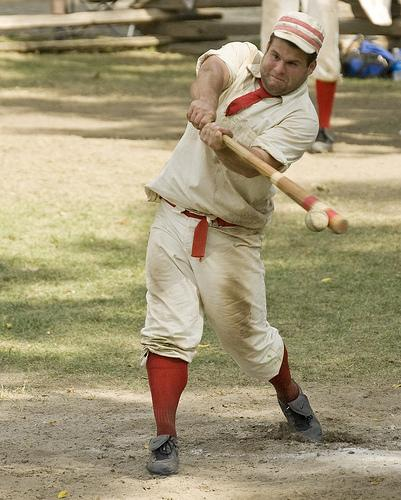State three details about the man's attire and accessories. The man is wearing a red and white hat, a red tie around his neck, and a red belt on his pants. List five objects you can see in the picture. A baseball player, wooden bat, red sock, black shoe, white baseball. What specific action is the baseball player attempting to perform? The baseball player is attempting to hit the white baseball coming towards him using a wooden bat. Mention the color and position of the sock and the shoe. The red sock is on the leg, and the black shoe is on the foot. In a dramatic fashion, describe the interaction between the baseball and the bat during the swing. As the white baseball soars through the air, the determined batter lunges his wooden bat with fierce calculation, destiny hurtling them towards a fateful collision. Describe the scene of the baseball player in a poetic style. Beneath a sky so fair and wide, the baseball player stands with pride, arms raised with wooden bat in hand, energy flows like shifting sand. Narrate what the man is doing in this image. The man clad in a baseball uniform is swinging the wooden bat to hit a white baseball in the air. Describe the man's surroundings in the picture. The man is surrounded by a wooden log fence, shadow on the ground, and brown dirt scattered around him. Mention three things the man is wearing and where each piece is located on his body. He wears a red and white hat on his head, a red belt in his pants, and black shoes on his feet. What event is taking place and how the man is involved in it? A baseball game is taking place, and the man is a player, actively swinging his bat to hit the ball. 